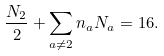Convert formula to latex. <formula><loc_0><loc_0><loc_500><loc_500>\frac { N _ { 2 } } { 2 } + \sum _ { a \neq 2 } n _ { a } N _ { a } = 1 6 .</formula> 